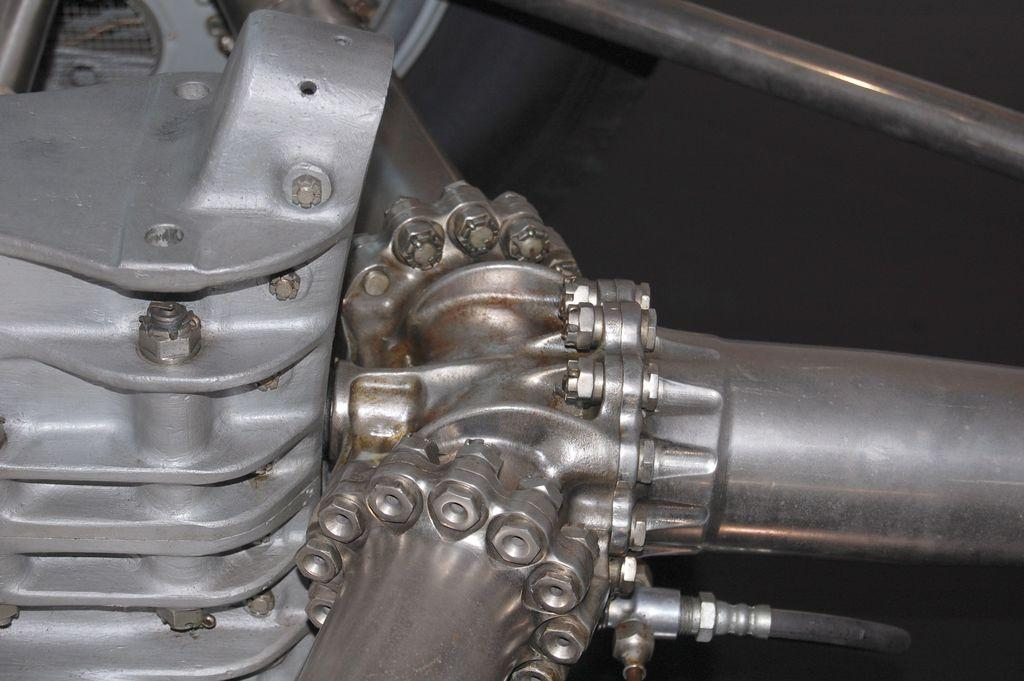What type of object is made of metal in the image? There is a metal object in the image. Can you describe the metal object in more detail? The metal object consists of metal pipes with nuts and bolts. Are there any other metal objects connected to the pipes? Yes, there is a pipe connected to the metal pipe in the image. What type of beetle can be seen crawling on the metal object in the image? There is no beetle present in the image; it only features metal objects and pipes. 